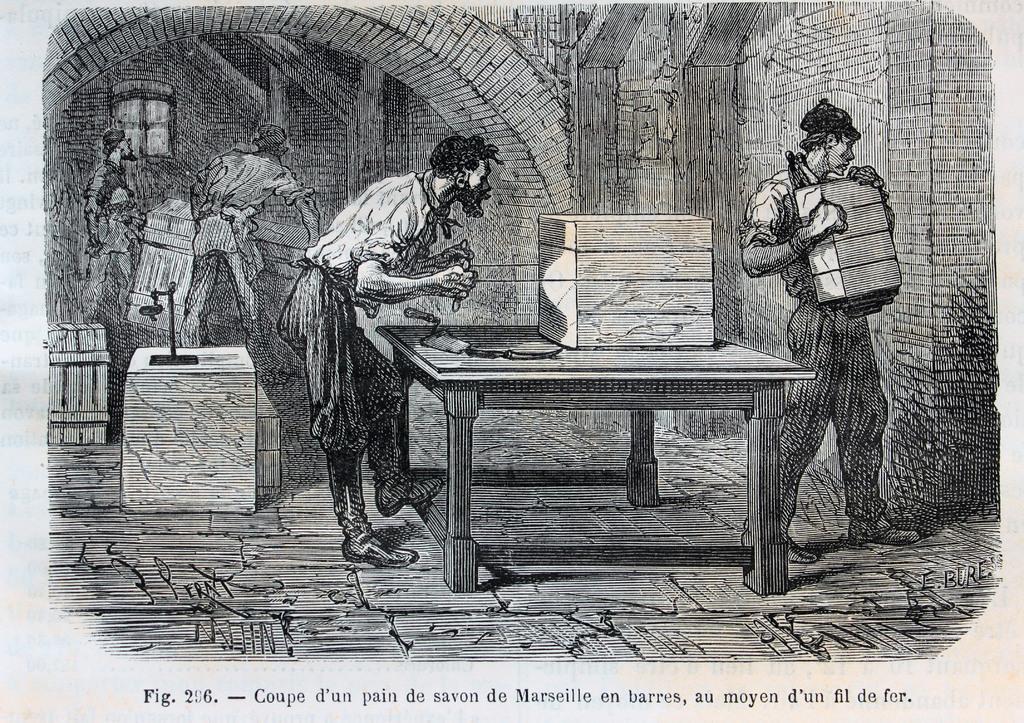In one or two sentences, can you explain what this image depicts? In the picture we can see a sketch of the two man standing under the old construction, one man is holding some bricks and one man is doing some work on the table. 